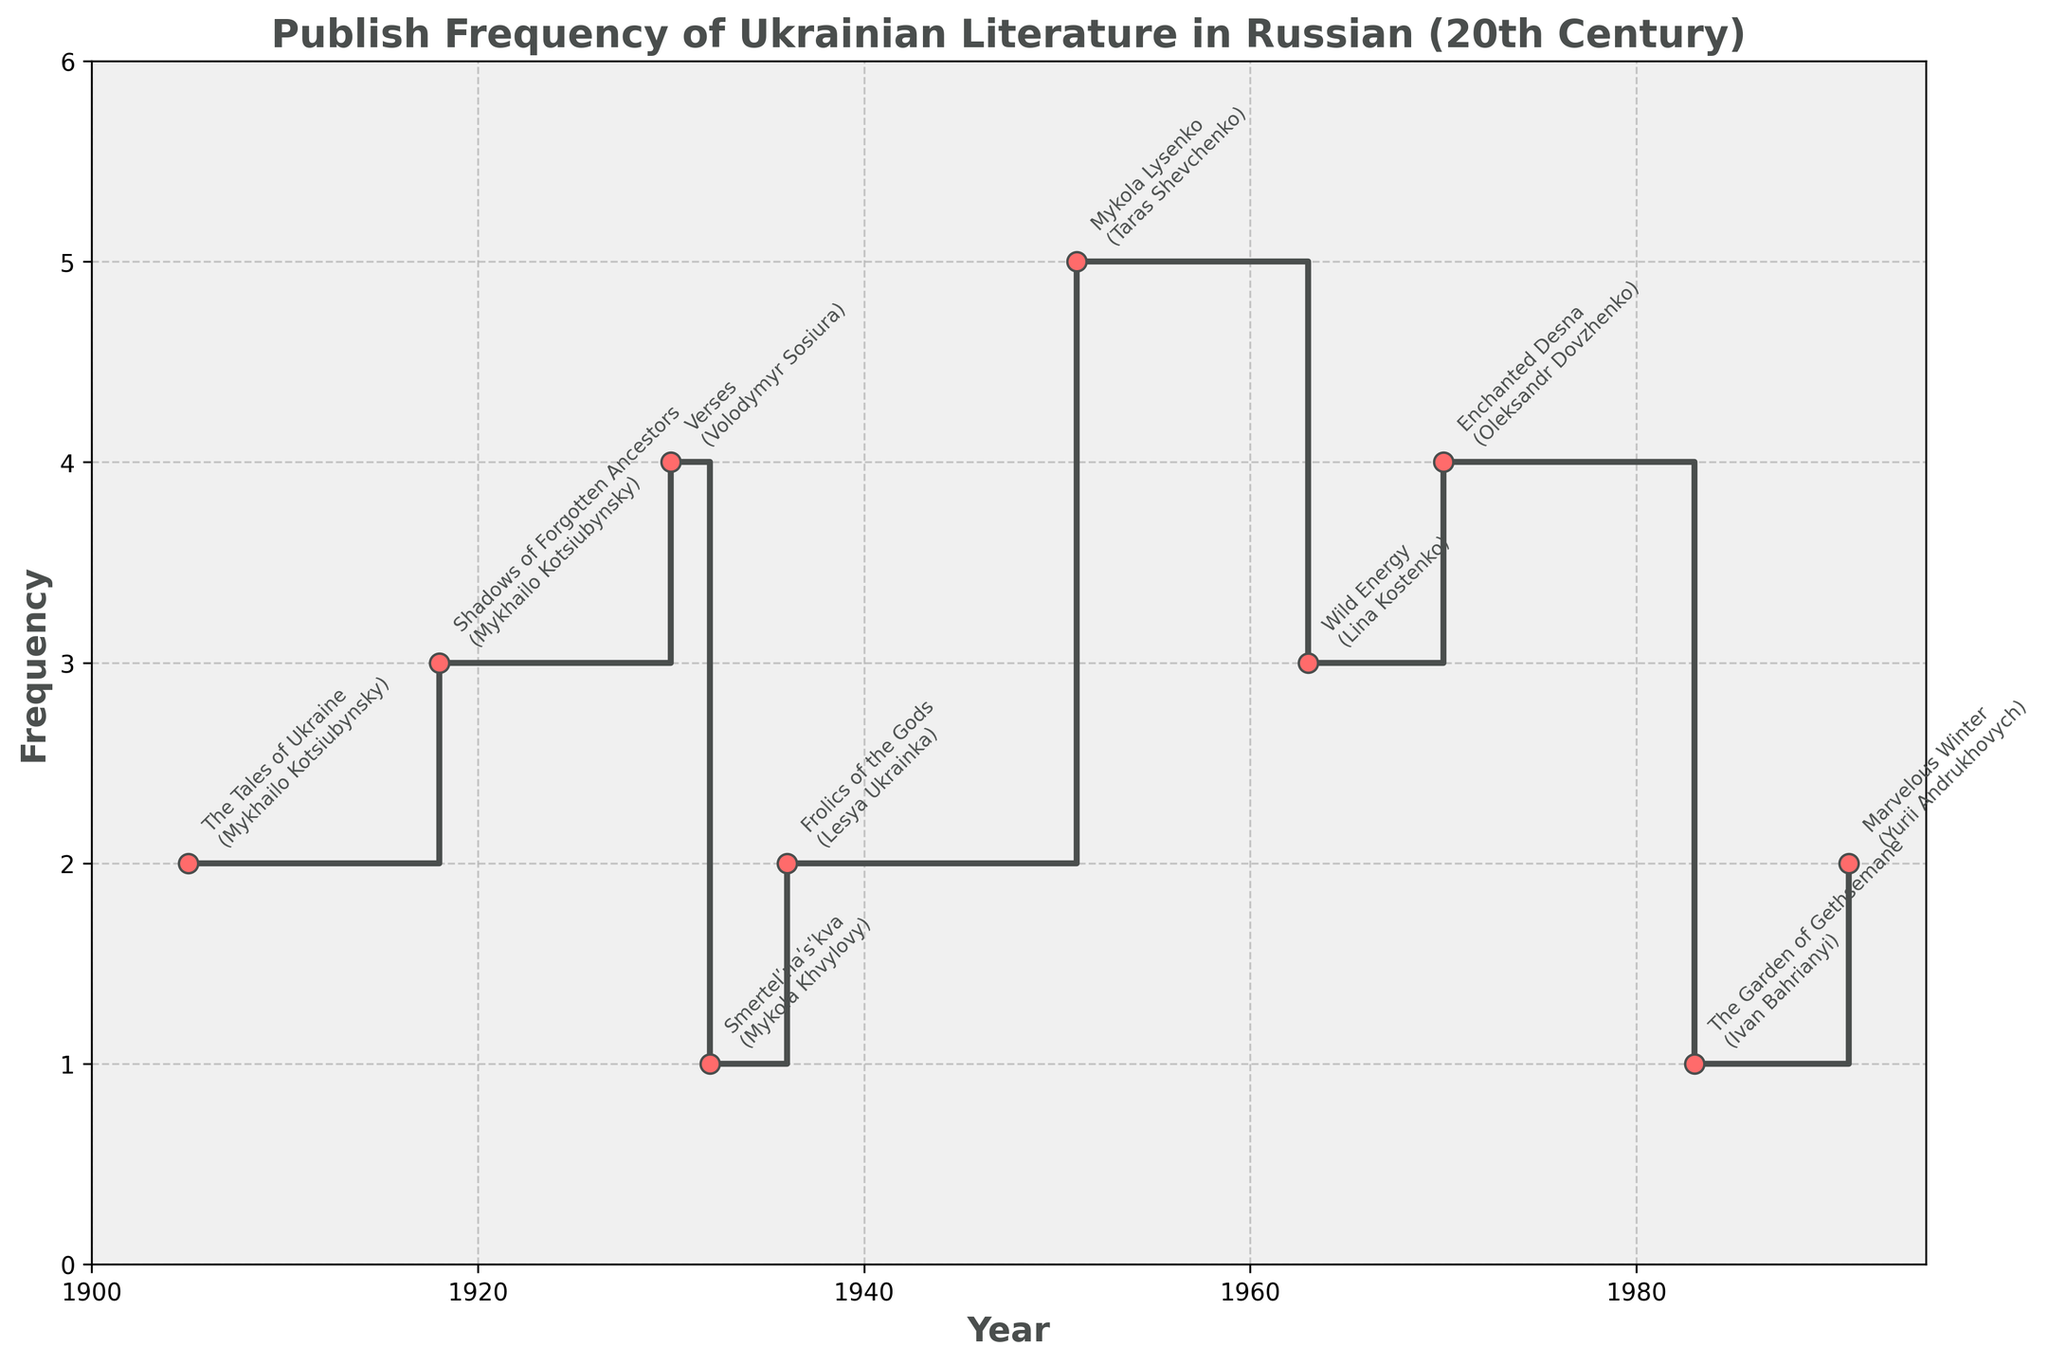What is the title of the plot? Look at the text at the top of the plot, which is typically the title.
Answer: Publish Frequency of Ukrainian Literature in Russian (20th Century) What are the x-axis and y-axis labeled as? The labels are usually found along the axes; the x-axis label is at the bottom, and the y-axis label is on the left side.
Answer: The x-axis is labeled 'Year', and the y-axis is labeled 'Frequency' How many data points are there in the plot? Each marker on the stair plot represents a data point. Count the markers.
Answer: 10 What is the highest publish frequency recorded? Look for the highest marker along the y-axis and read its value.
Answer: 5 Which literary work has the highest publish frequency? Identify the literary work associated with the highest marker.
Answer: Mykola Lysenko by Taras Shevchenko What is the median publish frequency value? Arrange the publish frequencies in ascending order and find the middle value. Since there are 10 data points, the median is the average of the 5th and 6th values. Arrange as [1, 1, 2, 2, 3, 3, 3, 4, 4, 5]. The median is (3+3)/2.
Answer: 3 Which author has more than one literary work in the plot? Look at the data points annotated; count the occurrences of each author.
Answer: Mykhailo Kotsiubynsky Which years had a publish frequency of 4? Look for the markers with a publish frequency of 4 and check the corresponding years on the x-axis.
Answer: 1930 and 1970 What is the difference in publish frequency between the years 1918 and 1936? Find the markers for the years 1918 and 1936 and compare their frequencies' values. The frequency for 1918 is 3, and for 1936, it is 2. Difference = 3 - 2.
Answer: 1 During which time period was the publish frequency consistently zero? Examine the plot for gaps in engage frequencies between consecutive years. Look for long periods with no markers or a frequency of zero.
Answer: 1951 to 1963 